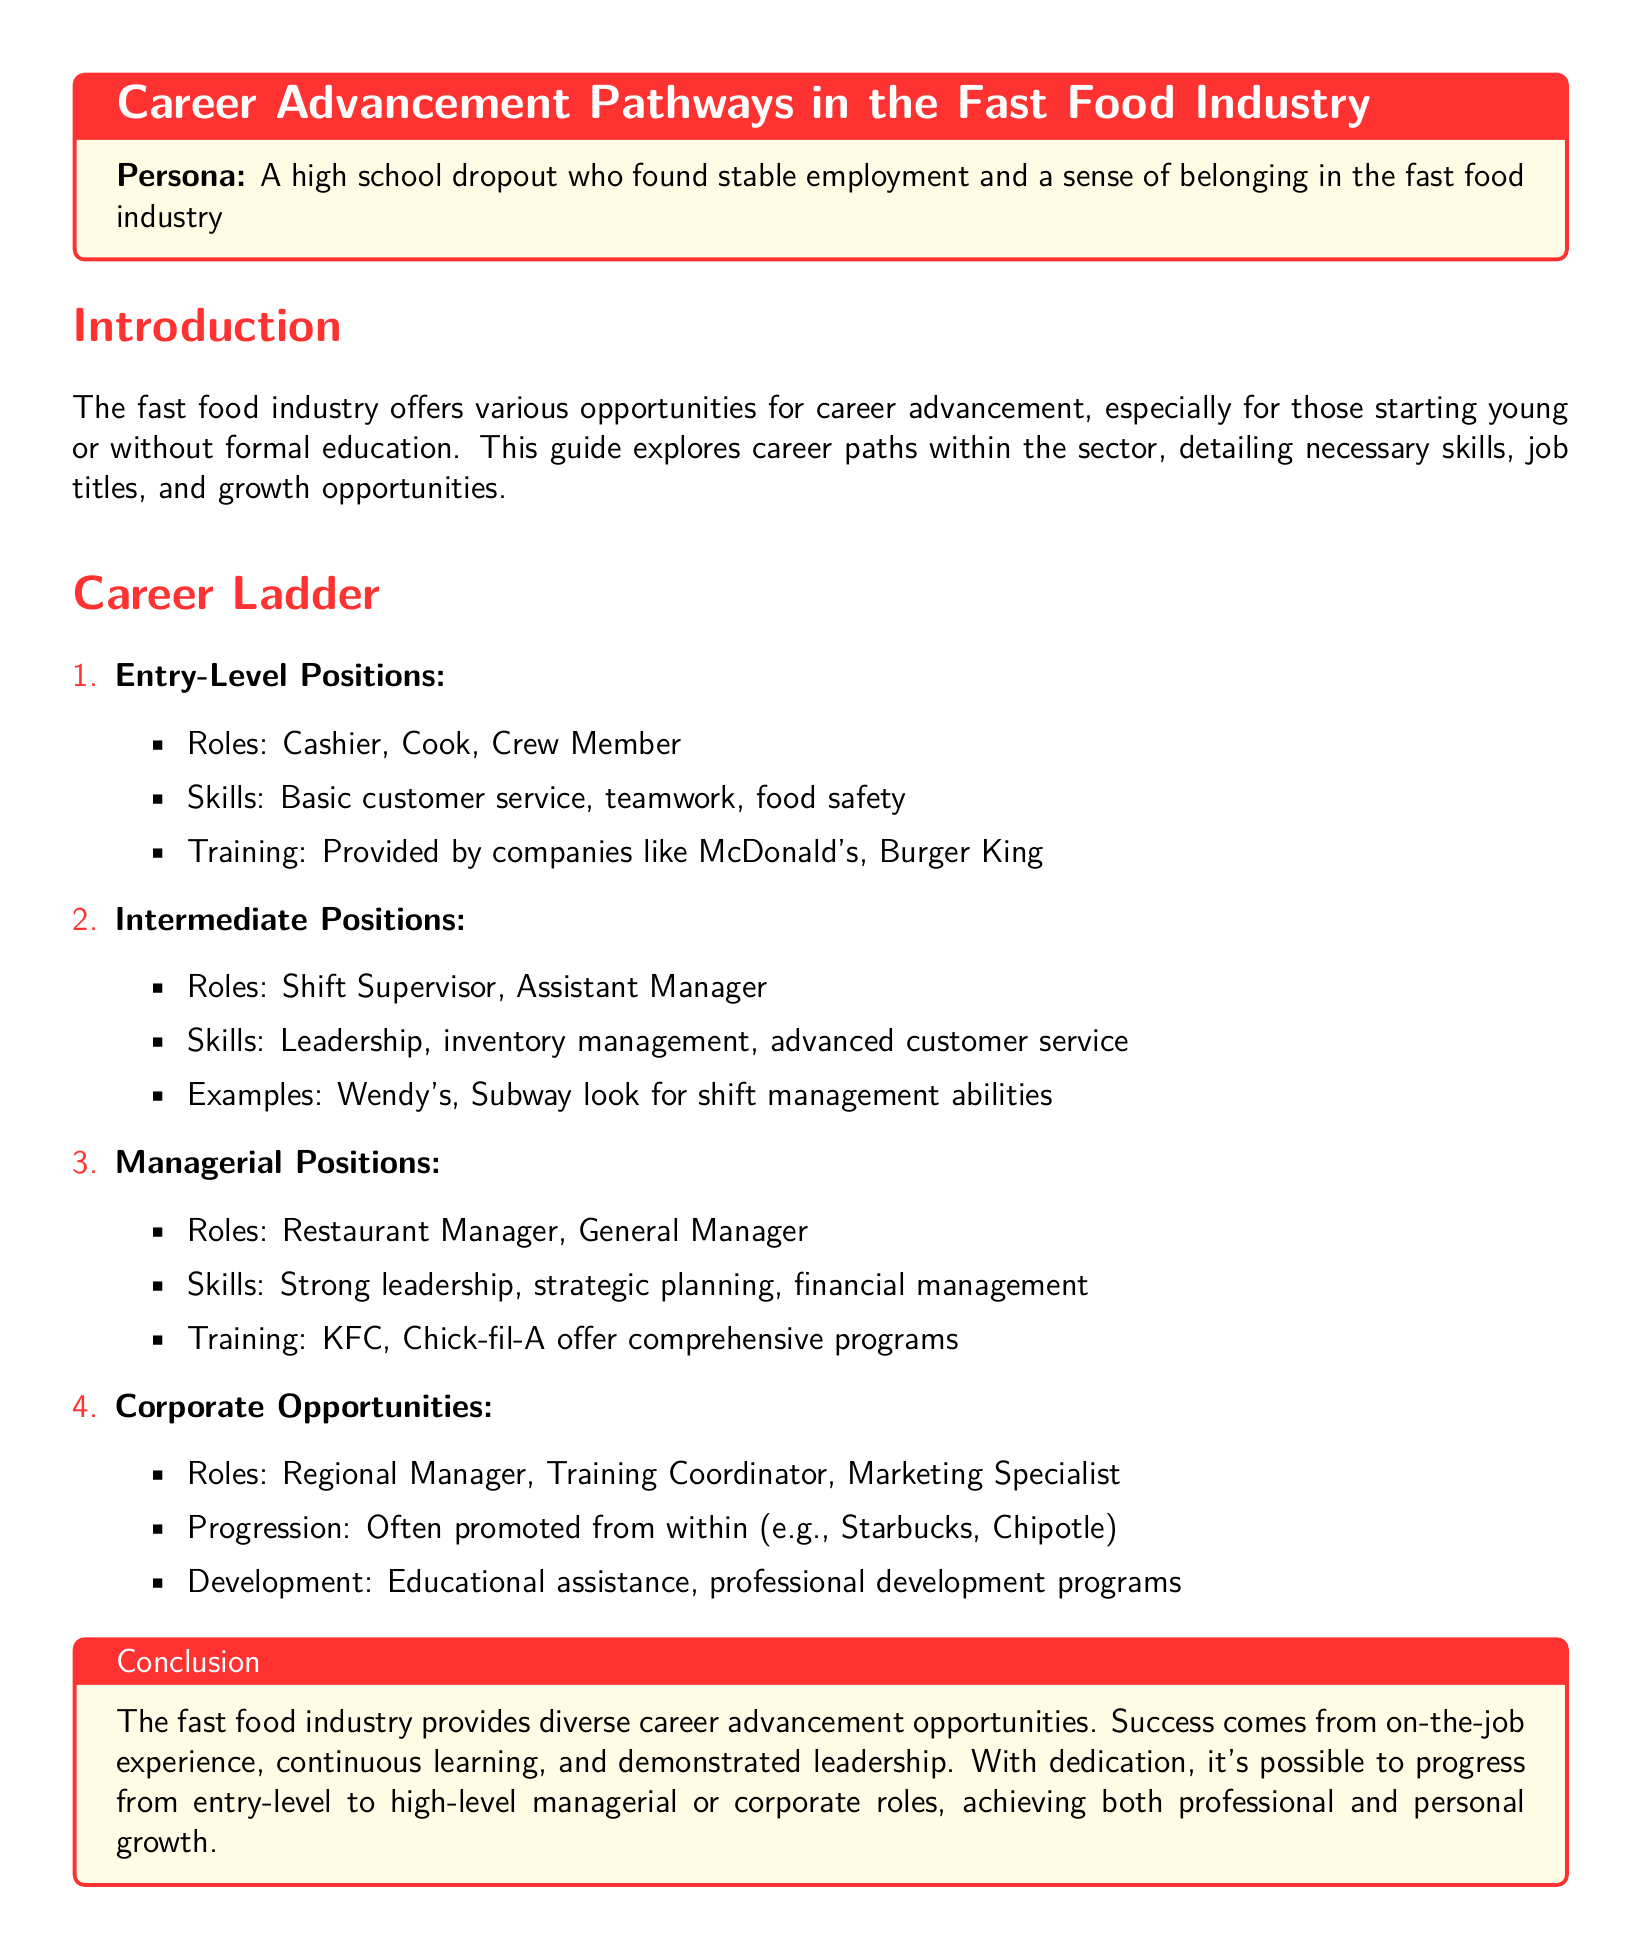what are examples of entry-level positions in fast food? The document lists cashiers, cooks, and crew members as examples of entry-level positions in the fast food industry.
Answer: Cashier, Cook, Crew Member what skills are necessary for intermediate positions? The necessary skills for intermediate positions include leadership, inventory management, and advanced customer service.
Answer: Leadership, Inventory Management, Advanced Customer Service which companies are mentioned for managerial training programs? The document mentions KFC and Chick-fil-A as companies that offer comprehensive training programs for managerial positions.
Answer: KFC, Chick-fil-A what growth opportunities exist at the corporate level? The document indicates that growth opportunities at the corporate level include roles such as Regional Manager, Training Coordinator, and Marketing Specialist.
Answer: Regional Manager, Training Coordinator, Marketing Specialist how can one progress to managerial positions? Progression to managerial positions often involves on-the-job experience, continuous learning, and demonstrated leadership, as stated in the conclusion.
Answer: On-the-job experience, Continuous learning, Demonstrated leadership which is a necessary skill for entry-level roles? The document lists basic customer service as a necessary skill for entry-level positions in the fast food industry.
Answer: Basic customer service what is the focus of training provided by companies like McDonald's? The document states that companies like McDonald's provide training focused on basic customer service, teamwork, and food safety for entry-level positions.
Answer: Basic customer service, Teamwork, Food safety which type of roles can be found at the corporate level? The corporate level offers roles such as Regional Manager, Training Coordinator, and Marketing Specialist, as mentioned in the document.
Answer: Regional Manager, Training Coordinator, Marketing Specialist 